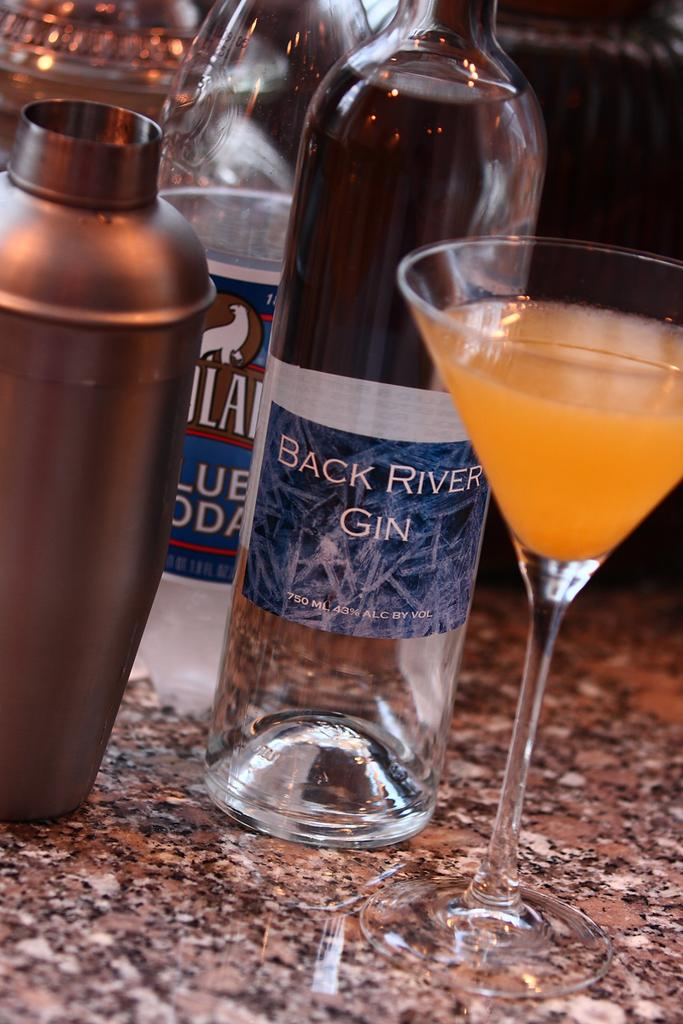<image>
Summarize the visual content of the image. A table with an orange colored cocktail and a bottle of Back River Gin. 